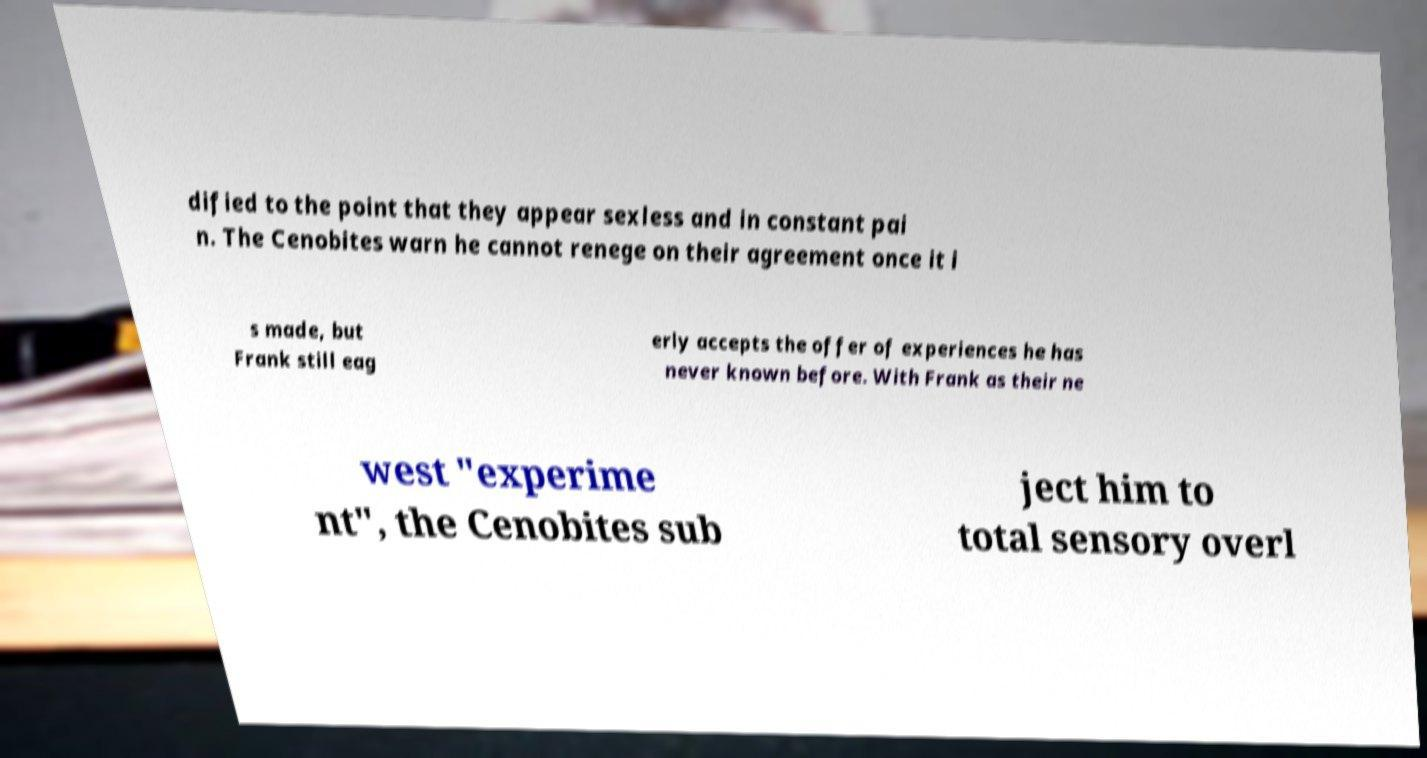Could you extract and type out the text from this image? dified to the point that they appear sexless and in constant pai n. The Cenobites warn he cannot renege on their agreement once it i s made, but Frank still eag erly accepts the offer of experiences he has never known before. With Frank as their ne west "experime nt", the Cenobites sub ject him to total sensory overl 